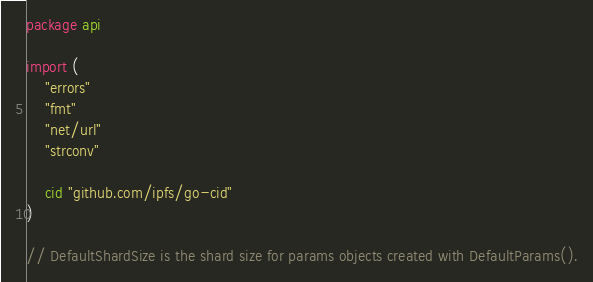<code> <loc_0><loc_0><loc_500><loc_500><_Go_>package api

import (
	"errors"
	"fmt"
	"net/url"
	"strconv"

	cid "github.com/ipfs/go-cid"
)

// DefaultShardSize is the shard size for params objects created with DefaultParams().</code> 